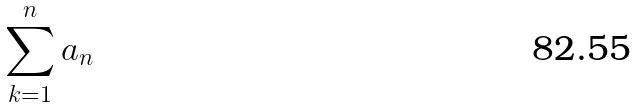<formula> <loc_0><loc_0><loc_500><loc_500>\sum _ { k = 1 } ^ { n } a _ { n }</formula> 